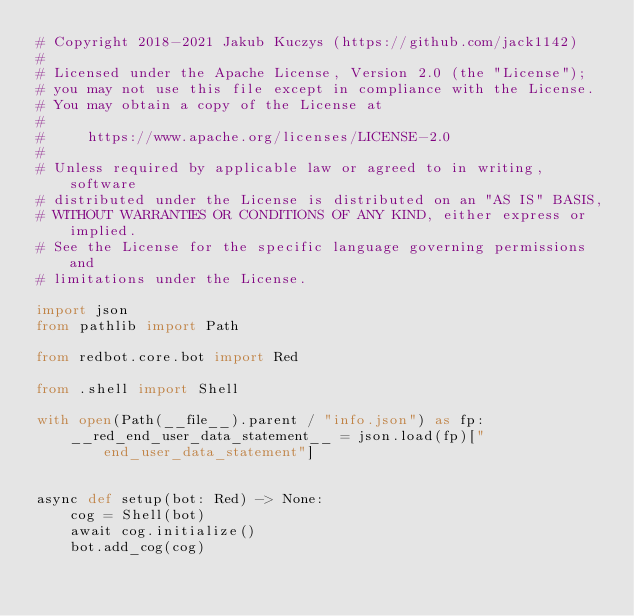Convert code to text. <code><loc_0><loc_0><loc_500><loc_500><_Python_># Copyright 2018-2021 Jakub Kuczys (https://github.com/jack1142)
#
# Licensed under the Apache License, Version 2.0 (the "License");
# you may not use this file except in compliance with the License.
# You may obtain a copy of the License at
#
#     https://www.apache.org/licenses/LICENSE-2.0
#
# Unless required by applicable law or agreed to in writing, software
# distributed under the License is distributed on an "AS IS" BASIS,
# WITHOUT WARRANTIES OR CONDITIONS OF ANY KIND, either express or implied.
# See the License for the specific language governing permissions and
# limitations under the License.

import json
from pathlib import Path

from redbot.core.bot import Red

from .shell import Shell

with open(Path(__file__).parent / "info.json") as fp:
    __red_end_user_data_statement__ = json.load(fp)["end_user_data_statement"]


async def setup(bot: Red) -> None:
    cog = Shell(bot)
    await cog.initialize()
    bot.add_cog(cog)
</code> 